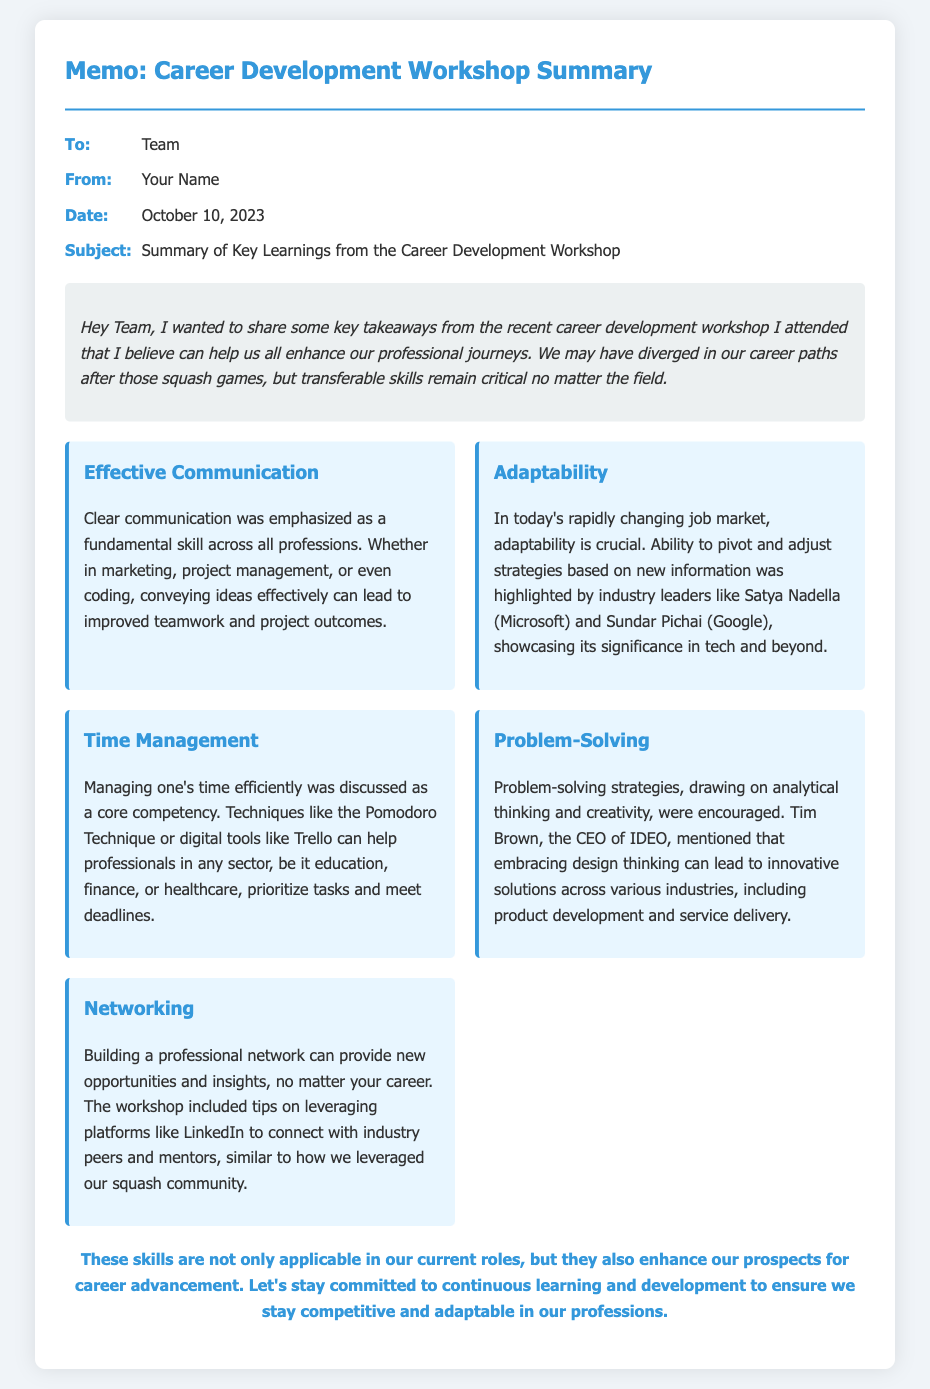what is the date of the memo? The date of the memo is explicitly mentioned in the meta section.
Answer: October 10, 2023 who emphasized the importance of adaptability? This information can be found in the section discussing adaptability, mentioning key industry leaders.
Answer: Satya Nadella and Sundar Pichai what was one suggested technique for time management? This detail is listed under time management learning, providing specific methods.
Answer: Pomodoro Technique which skill was connected to improving teamwork? This is highlighted in the effective communication section of the memo.
Answer: Effective Communication what networking platform was mentioned? The memo specifically refers to a platform to connect with peers and mentors.
Answer: LinkedIn how many key learnings were outlined in the document? The number of key learnings can be inferred from the learning items discussed in the memo.
Answer: Five 